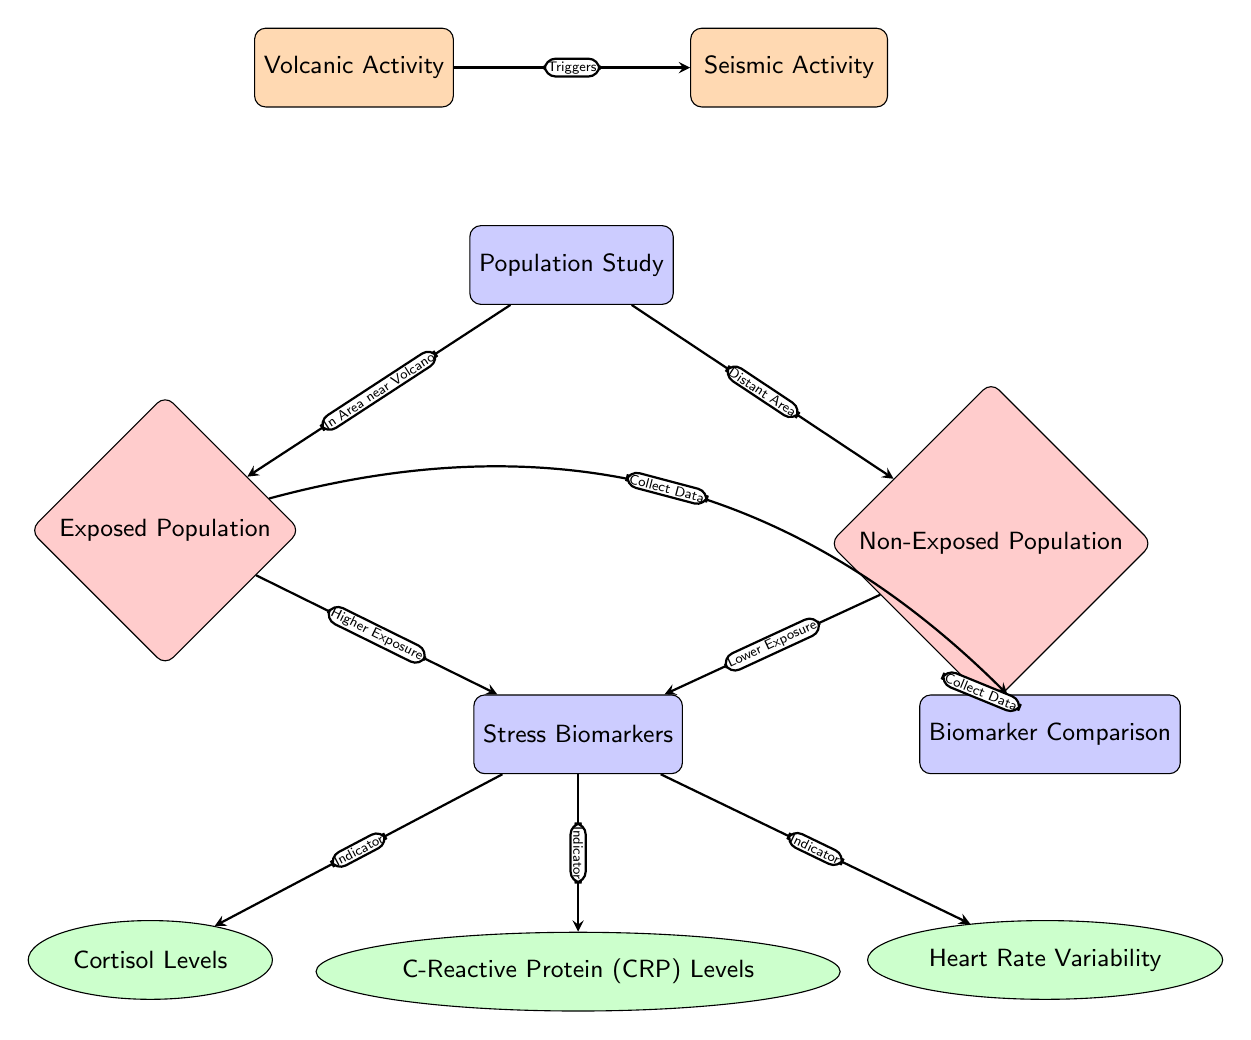What are the two types of populations studied? The diagram identifies "Exposed Population" and "Non-Exposed Population" as two distinct groups involved in the population study.
Answer: Exposed Population, Non-Exposed Population What is one of the indicators of stress biomarkers listed in the diagram? The diagram shows three indicators of stress biomarkers: Cortisol Levels, C-Reactive Protein (CRP) Levels, and Heart Rate Variability. Any of these can be considered correct.
Answer: Cortisol Levels How does volcanic activity relate to seismic activity? The diagram illustrates that volcanic activity "Triggers" seismic activity, indicating a cause-and-effect relationship between the two.
Answer: Triggers What type of data is collected from the exposed population? The arrows leading from "Exposed Population" to "Biomarker Comparison" indicate that data about stress biomarkers is collected from this group.
Answer: Collect Data Which population is indicated to have "Higher Exposure"? The arrows connecting "Exposed Population" to "Stress Biomarkers" specify that this population is associated with "Higher Exposure," suggesting they experience more stress-related impacts.
Answer: Exposed Population What follows the stress biomarkers in the hierarchy? The diagram shows that "Stress Biomarkers" leads to specific indicators such as Cortisol Levels, CRP Levels, and Heart Rate Variability, making these the next step downstream.
Answer: Cortisol Levels, CRP Levels, Heart Rate Variability How many indicators of stress biomarkers are specified in the diagram? The diagram lists three indicators of stress biomarkers – Cortisol Levels, C-Reactive Protein (CRP) Levels, and Heart Rate Variability, thus representing a count of three.
Answer: 3 What does the "Population Study" node connect to? The diagram shows connections from the "Population Study" to both the "Exposed Population" and "Non-Exposed Population," indicating two pathways stemming from this node.
Answer: Exposed Population, Non-Exposed Population Which population is associated with lower levels of exposure? The diagram connects "Non-Exposed Population" with "Lower Exposure," clearly marking them as the group with less contact with volcanic activity.
Answer: Non-Exposed Population 